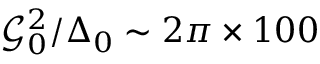Convert formula to latex. <formula><loc_0><loc_0><loc_500><loc_500>\mathcal { G } _ { 0 } ^ { 2 } / \Delta _ { 0 } \sim 2 \pi \times 1 0 0</formula> 